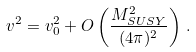<formula> <loc_0><loc_0><loc_500><loc_500>v ^ { 2 } = v _ { 0 } ^ { 2 } + O \left ( \frac { M _ { S U S Y } ^ { 2 } } { ( 4 \pi ) ^ { 2 } } \right ) \, .</formula> 